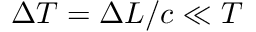Convert formula to latex. <formula><loc_0><loc_0><loc_500><loc_500>\Delta T = \Delta L / c \ll T</formula> 